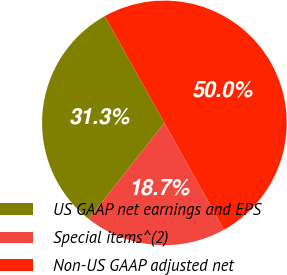<chart> <loc_0><loc_0><loc_500><loc_500><pie_chart><fcel>US GAAP net earnings and EPS<fcel>Special items^(2)<fcel>Non-US GAAP adjusted net<nl><fcel>31.28%<fcel>18.72%<fcel>50.0%<nl></chart> 